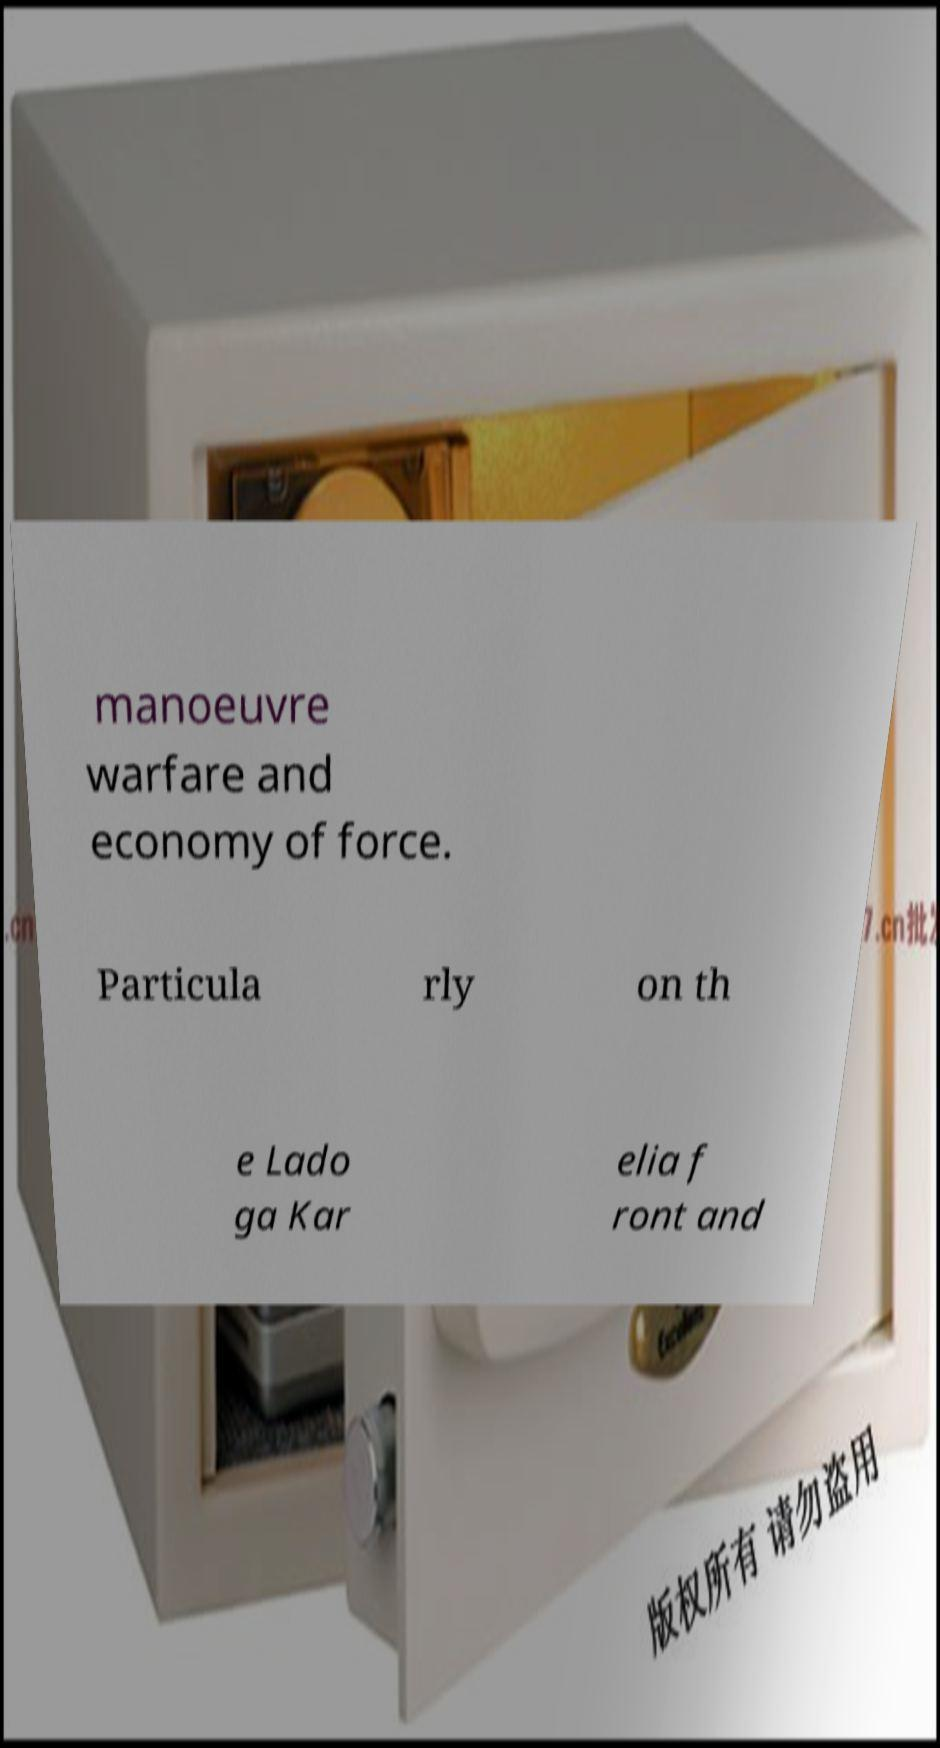What messages or text are displayed in this image? I need them in a readable, typed format. manoeuvre warfare and economy of force. Particula rly on th e Lado ga Kar elia f ront and 